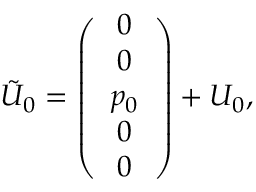<formula> <loc_0><loc_0><loc_500><loc_500>\tilde { U } _ { 0 } = \left ( \begin{array} { c } { 0 } \\ { 0 } \\ { { p _ { 0 } } } \\ { 0 } \\ { 0 } \end{array} \right ) + U _ { 0 } ,</formula> 